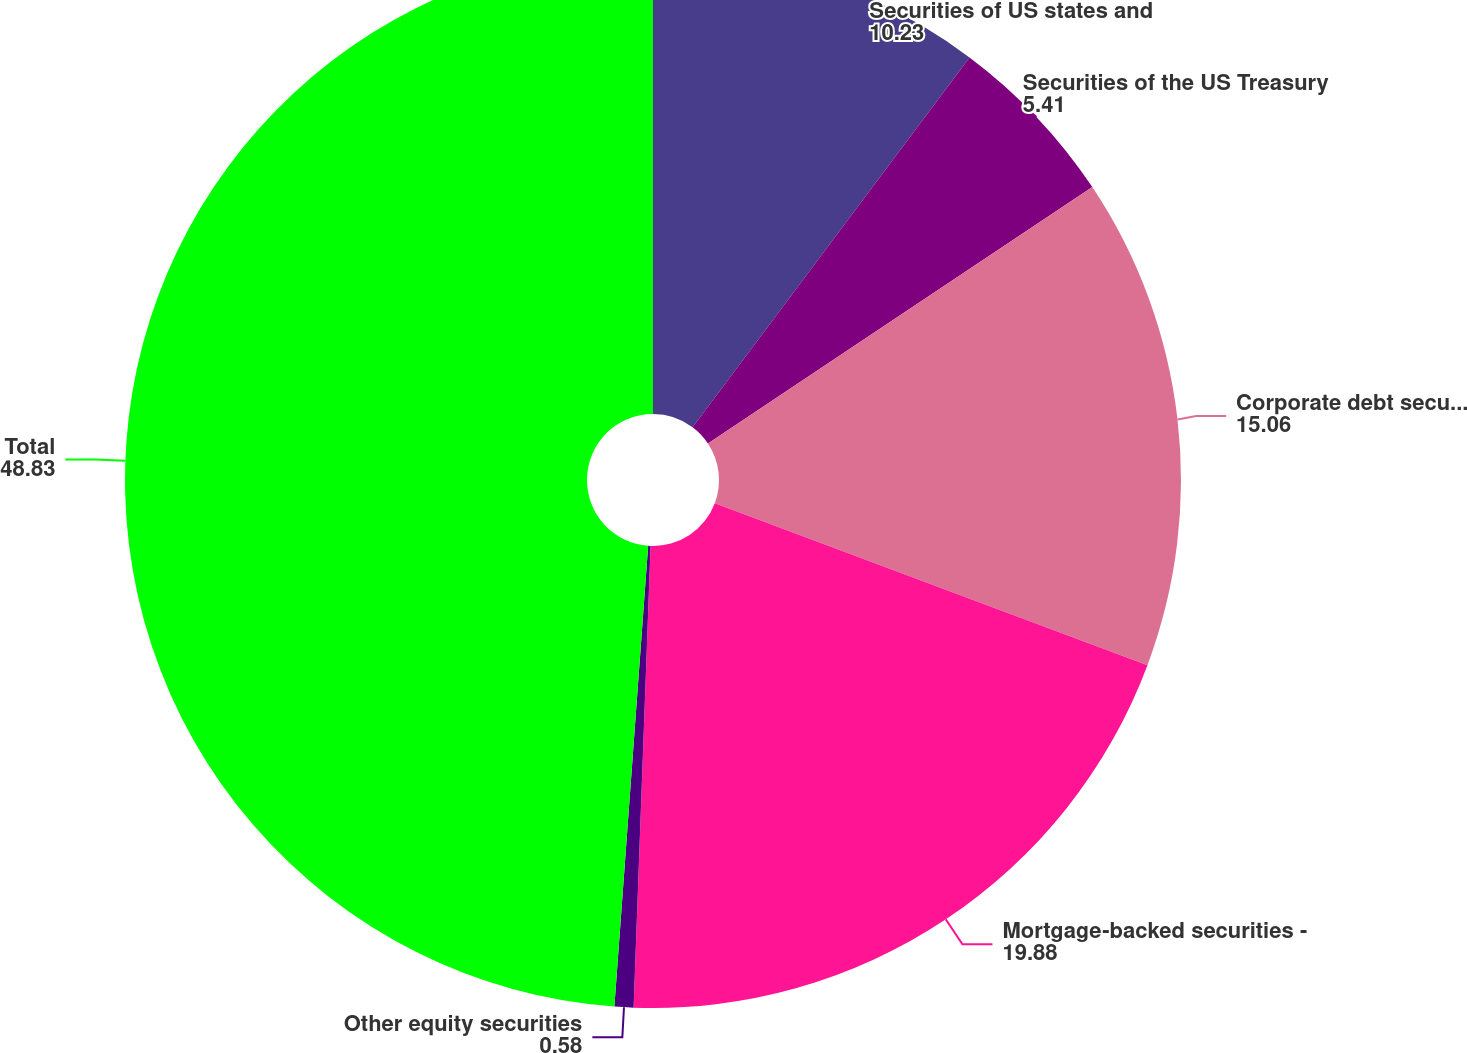Convert chart to OTSL. <chart><loc_0><loc_0><loc_500><loc_500><pie_chart><fcel>Securities of US states and<fcel>Securities of the US Treasury<fcel>Corporate debt securities<fcel>Mortgage-backed securities -<fcel>Other equity securities<fcel>Total<nl><fcel>10.23%<fcel>5.41%<fcel>15.06%<fcel>19.88%<fcel>0.58%<fcel>48.83%<nl></chart> 